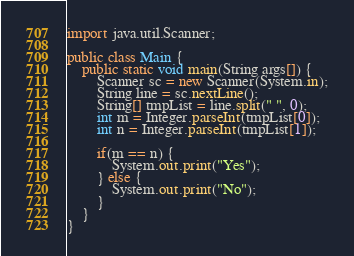Convert code to text. <code><loc_0><loc_0><loc_500><loc_500><_Java_>import java.util.Scanner;

public class Main {
	public static void main(String args[]) {
		Scanner sc = new Scanner(System.in);
		String line = sc.nextLine();
		String[] tmpList = line.split(" ", 0);
		int m = Integer.parseInt(tmpList[0]);
		int n = Integer.parseInt(tmpList[1]);

		if(m == n) {
			System.out.print("Yes");
		} else {
			System.out.print("No");
		}
	}
}</code> 